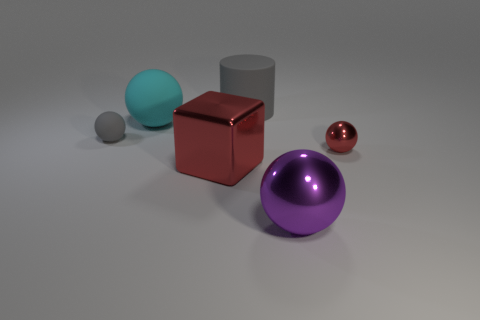Subtract all yellow spheres. Subtract all cyan cylinders. How many spheres are left? 4 Add 2 tiny brown metallic balls. How many objects exist? 8 Subtract all balls. How many objects are left? 2 Add 3 large red shiny objects. How many large red shiny objects exist? 4 Subtract 1 gray balls. How many objects are left? 5 Subtract all tiny rubber objects. Subtract all gray matte spheres. How many objects are left? 4 Add 3 big rubber balls. How many big rubber balls are left? 4 